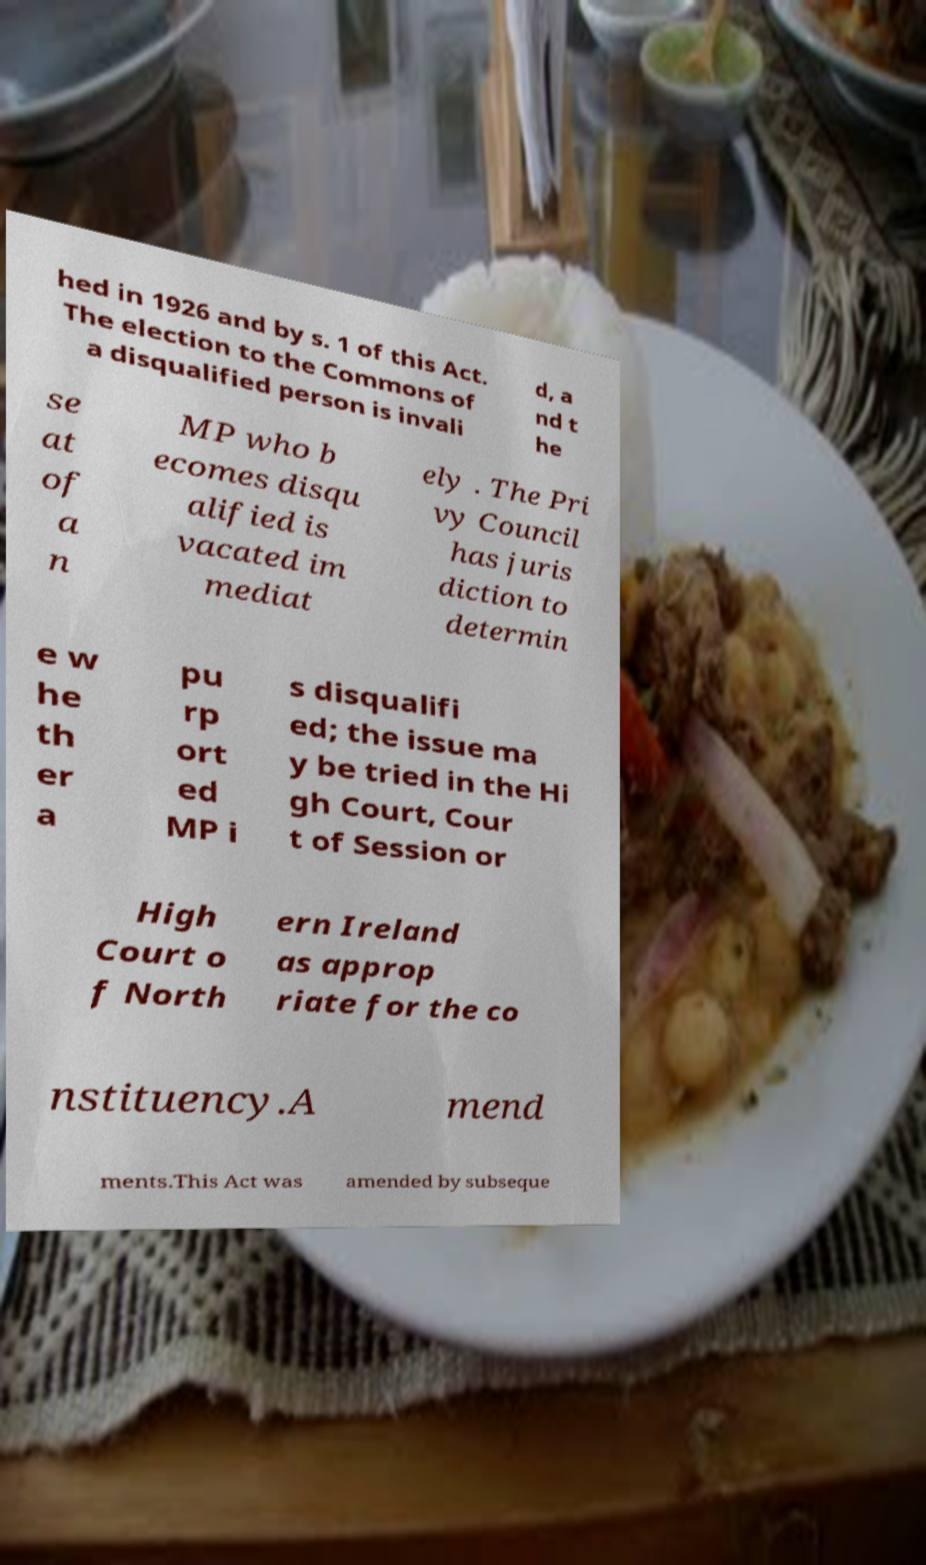Could you assist in decoding the text presented in this image and type it out clearly? hed in 1926 and by s. 1 of this Act. The election to the Commons of a disqualified person is invali d, a nd t he se at of a n MP who b ecomes disqu alified is vacated im mediat ely . The Pri vy Council has juris diction to determin e w he th er a pu rp ort ed MP i s disqualifi ed; the issue ma y be tried in the Hi gh Court, Cour t of Session or High Court o f North ern Ireland as approp riate for the co nstituency.A mend ments.This Act was amended by subseque 